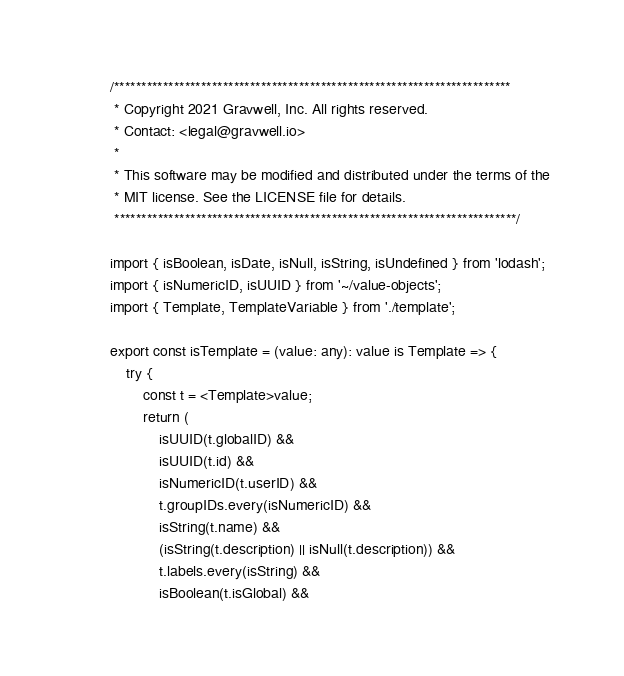<code> <loc_0><loc_0><loc_500><loc_500><_TypeScript_>/*************************************************************************
 * Copyright 2021 Gravwell, Inc. All rights reserved.
 * Contact: <legal@gravwell.io>
 *
 * This software may be modified and distributed under the terms of the
 * MIT license. See the LICENSE file for details.
 **************************************************************************/

import { isBoolean, isDate, isNull, isString, isUndefined } from 'lodash';
import { isNumericID, isUUID } from '~/value-objects';
import { Template, TemplateVariable } from './template';

export const isTemplate = (value: any): value is Template => {
	try {
		const t = <Template>value;
		return (
			isUUID(t.globalID) &&
			isUUID(t.id) &&
			isNumericID(t.userID) &&
			t.groupIDs.every(isNumericID) &&
			isString(t.name) &&
			(isString(t.description) || isNull(t.description)) &&
			t.labels.every(isString) &&
			isBoolean(t.isGlobal) &&</code> 